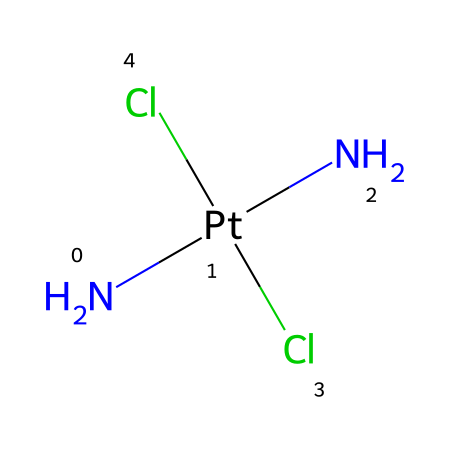What is the metal center in cisplatin? The chemical structure shows a central platinum atom (Pt) that is surrounded by ligands, which identifies it as the metal center of cisplatin.
Answer: platinum How many chlorine atoms are present in cisplatin? By examining the structure, we see two chlorine atoms (Cl) directly bonded to the platinum atom, indicating the count.
Answer: two What type of bonding is primarily involved in cisplatin? The chemical structure indicates coordination between the platinum atom and the surrounding ligands, which shows that coordination bonds are the primary type of bonding present.
Answer: coordination What is the molecular geometry of cisplatin? Given the arrangement of ligands around the platinum atom, the geometry can be inferred as square planar, typical for d8 metal complexes such as cisplatin.
Answer: square planar Which ligands are coordinated to the platinum in cisplatin? The visual structure clearly indicates that there are both chloride (Cl) and amine (N) ligands attached to the platinum atom, which are characteristic of the configuration.
Answer: chloride and amine What type of organometallic compound is cisplatin categorized as? Based on the presence of both metal and organic components (in this case, amines and chlorides) serving as ligands to the metal, cisplatin is categorized as a coordination complex, which is a sub-type of organometallic compounds.
Answer: coordination complex How does the arrangement of ligands in cisplatin relate to its function as an anticancer drug? The specific geometrical arrangement (square planar) of the ligands allows for effective interaction with DNA in cancer cells, hence its functionality as an anticancer drug. This structure is critical for its biological activity.
Answer: effective interaction with DNA 